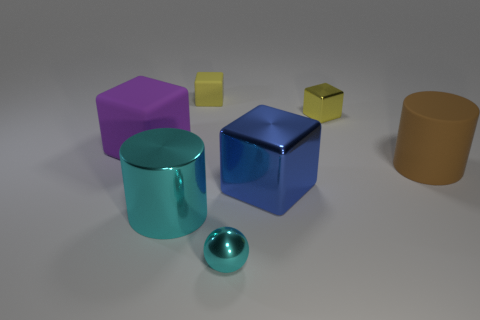How many objects are there in total, and can you describe their shapes? There are six objects in total, consisting of a cylinder, a small sphere, a large cube, a small cube, a rectangular prism, and a tall cylinder with the top circle slightly larger than the bottom one. 